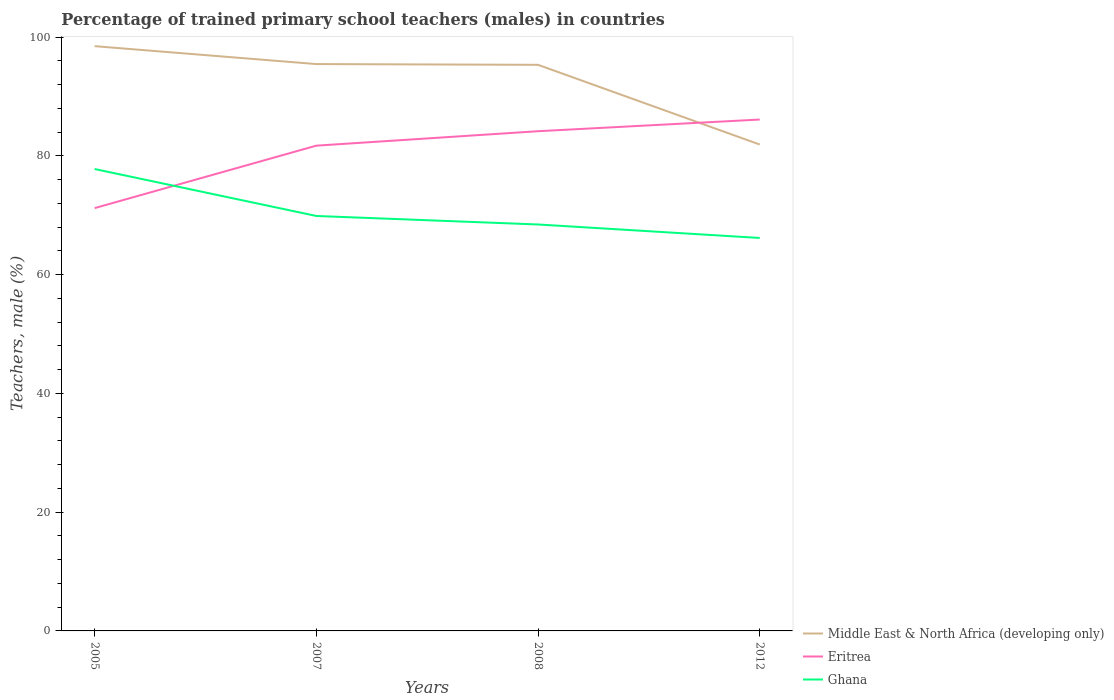Does the line corresponding to Ghana intersect with the line corresponding to Eritrea?
Give a very brief answer. Yes. Across all years, what is the maximum percentage of trained primary school teachers (males) in Middle East & North Africa (developing only)?
Make the answer very short. 81.9. In which year was the percentage of trained primary school teachers (males) in Ghana maximum?
Give a very brief answer. 2012. What is the total percentage of trained primary school teachers (males) in Eritrea in the graph?
Offer a very short reply. -2.43. What is the difference between the highest and the second highest percentage of trained primary school teachers (males) in Eritrea?
Keep it short and to the point. 14.91. What is the difference between the highest and the lowest percentage of trained primary school teachers (males) in Ghana?
Your answer should be very brief. 1. How many years are there in the graph?
Offer a terse response. 4. What is the difference between two consecutive major ticks on the Y-axis?
Provide a succinct answer. 20. Does the graph contain any zero values?
Provide a succinct answer. No. Does the graph contain grids?
Your answer should be very brief. No. How many legend labels are there?
Give a very brief answer. 3. How are the legend labels stacked?
Keep it short and to the point. Vertical. What is the title of the graph?
Ensure brevity in your answer.  Percentage of trained primary school teachers (males) in countries. What is the label or title of the X-axis?
Your response must be concise. Years. What is the label or title of the Y-axis?
Your answer should be compact. Teachers, male (%). What is the Teachers, male (%) in Middle East & North Africa (developing only) in 2005?
Your answer should be compact. 98.46. What is the Teachers, male (%) of Eritrea in 2005?
Provide a short and direct response. 71.19. What is the Teachers, male (%) in Ghana in 2005?
Your answer should be compact. 77.77. What is the Teachers, male (%) in Middle East & North Africa (developing only) in 2007?
Provide a short and direct response. 95.45. What is the Teachers, male (%) in Eritrea in 2007?
Give a very brief answer. 81.71. What is the Teachers, male (%) in Ghana in 2007?
Provide a short and direct response. 69.87. What is the Teachers, male (%) of Middle East & North Africa (developing only) in 2008?
Your response must be concise. 95.32. What is the Teachers, male (%) in Eritrea in 2008?
Provide a short and direct response. 84.14. What is the Teachers, male (%) of Ghana in 2008?
Your response must be concise. 68.44. What is the Teachers, male (%) of Middle East & North Africa (developing only) in 2012?
Make the answer very short. 81.9. What is the Teachers, male (%) in Eritrea in 2012?
Keep it short and to the point. 86.11. What is the Teachers, male (%) in Ghana in 2012?
Offer a very short reply. 66.17. Across all years, what is the maximum Teachers, male (%) in Middle East & North Africa (developing only)?
Provide a short and direct response. 98.46. Across all years, what is the maximum Teachers, male (%) in Eritrea?
Offer a terse response. 86.11. Across all years, what is the maximum Teachers, male (%) of Ghana?
Ensure brevity in your answer.  77.77. Across all years, what is the minimum Teachers, male (%) of Middle East & North Africa (developing only)?
Ensure brevity in your answer.  81.9. Across all years, what is the minimum Teachers, male (%) of Eritrea?
Offer a very short reply. 71.19. Across all years, what is the minimum Teachers, male (%) of Ghana?
Offer a terse response. 66.17. What is the total Teachers, male (%) of Middle East & North Africa (developing only) in the graph?
Your answer should be compact. 371.12. What is the total Teachers, male (%) of Eritrea in the graph?
Your response must be concise. 323.15. What is the total Teachers, male (%) of Ghana in the graph?
Offer a very short reply. 282.24. What is the difference between the Teachers, male (%) of Middle East & North Africa (developing only) in 2005 and that in 2007?
Your answer should be very brief. 3.01. What is the difference between the Teachers, male (%) in Eritrea in 2005 and that in 2007?
Keep it short and to the point. -10.51. What is the difference between the Teachers, male (%) of Ghana in 2005 and that in 2007?
Your answer should be compact. 7.9. What is the difference between the Teachers, male (%) of Middle East & North Africa (developing only) in 2005 and that in 2008?
Keep it short and to the point. 3.14. What is the difference between the Teachers, male (%) in Eritrea in 2005 and that in 2008?
Ensure brevity in your answer.  -12.95. What is the difference between the Teachers, male (%) of Ghana in 2005 and that in 2008?
Offer a very short reply. 9.34. What is the difference between the Teachers, male (%) in Middle East & North Africa (developing only) in 2005 and that in 2012?
Offer a terse response. 16.56. What is the difference between the Teachers, male (%) in Eritrea in 2005 and that in 2012?
Your answer should be compact. -14.91. What is the difference between the Teachers, male (%) in Ghana in 2005 and that in 2012?
Your answer should be compact. 11.61. What is the difference between the Teachers, male (%) in Middle East & North Africa (developing only) in 2007 and that in 2008?
Your answer should be very brief. 0.13. What is the difference between the Teachers, male (%) in Eritrea in 2007 and that in 2008?
Make the answer very short. -2.43. What is the difference between the Teachers, male (%) in Ghana in 2007 and that in 2008?
Your answer should be very brief. 1.43. What is the difference between the Teachers, male (%) of Middle East & North Africa (developing only) in 2007 and that in 2012?
Provide a short and direct response. 13.55. What is the difference between the Teachers, male (%) of Eritrea in 2007 and that in 2012?
Give a very brief answer. -4.4. What is the difference between the Teachers, male (%) in Ghana in 2007 and that in 2012?
Offer a very short reply. 3.7. What is the difference between the Teachers, male (%) of Middle East & North Africa (developing only) in 2008 and that in 2012?
Offer a very short reply. 13.42. What is the difference between the Teachers, male (%) of Eritrea in 2008 and that in 2012?
Make the answer very short. -1.97. What is the difference between the Teachers, male (%) in Ghana in 2008 and that in 2012?
Provide a short and direct response. 2.27. What is the difference between the Teachers, male (%) of Middle East & North Africa (developing only) in 2005 and the Teachers, male (%) of Eritrea in 2007?
Your response must be concise. 16.75. What is the difference between the Teachers, male (%) in Middle East & North Africa (developing only) in 2005 and the Teachers, male (%) in Ghana in 2007?
Provide a succinct answer. 28.59. What is the difference between the Teachers, male (%) of Eritrea in 2005 and the Teachers, male (%) of Ghana in 2007?
Ensure brevity in your answer.  1.32. What is the difference between the Teachers, male (%) of Middle East & North Africa (developing only) in 2005 and the Teachers, male (%) of Eritrea in 2008?
Give a very brief answer. 14.32. What is the difference between the Teachers, male (%) of Middle East & North Africa (developing only) in 2005 and the Teachers, male (%) of Ghana in 2008?
Your response must be concise. 30.03. What is the difference between the Teachers, male (%) in Eritrea in 2005 and the Teachers, male (%) in Ghana in 2008?
Give a very brief answer. 2.76. What is the difference between the Teachers, male (%) in Middle East & North Africa (developing only) in 2005 and the Teachers, male (%) in Eritrea in 2012?
Offer a terse response. 12.35. What is the difference between the Teachers, male (%) in Middle East & North Africa (developing only) in 2005 and the Teachers, male (%) in Ghana in 2012?
Your answer should be compact. 32.29. What is the difference between the Teachers, male (%) of Eritrea in 2005 and the Teachers, male (%) of Ghana in 2012?
Offer a terse response. 5.03. What is the difference between the Teachers, male (%) in Middle East & North Africa (developing only) in 2007 and the Teachers, male (%) in Eritrea in 2008?
Your answer should be very brief. 11.31. What is the difference between the Teachers, male (%) of Middle East & North Africa (developing only) in 2007 and the Teachers, male (%) of Ghana in 2008?
Keep it short and to the point. 27.01. What is the difference between the Teachers, male (%) in Eritrea in 2007 and the Teachers, male (%) in Ghana in 2008?
Your response must be concise. 13.27. What is the difference between the Teachers, male (%) of Middle East & North Africa (developing only) in 2007 and the Teachers, male (%) of Eritrea in 2012?
Provide a short and direct response. 9.34. What is the difference between the Teachers, male (%) of Middle East & North Africa (developing only) in 2007 and the Teachers, male (%) of Ghana in 2012?
Give a very brief answer. 29.28. What is the difference between the Teachers, male (%) of Eritrea in 2007 and the Teachers, male (%) of Ghana in 2012?
Keep it short and to the point. 15.54. What is the difference between the Teachers, male (%) of Middle East & North Africa (developing only) in 2008 and the Teachers, male (%) of Eritrea in 2012?
Make the answer very short. 9.21. What is the difference between the Teachers, male (%) in Middle East & North Africa (developing only) in 2008 and the Teachers, male (%) in Ghana in 2012?
Keep it short and to the point. 29.15. What is the difference between the Teachers, male (%) of Eritrea in 2008 and the Teachers, male (%) of Ghana in 2012?
Offer a very short reply. 17.97. What is the average Teachers, male (%) in Middle East & North Africa (developing only) per year?
Give a very brief answer. 92.78. What is the average Teachers, male (%) in Eritrea per year?
Your answer should be very brief. 80.79. What is the average Teachers, male (%) in Ghana per year?
Provide a succinct answer. 70.56. In the year 2005, what is the difference between the Teachers, male (%) of Middle East & North Africa (developing only) and Teachers, male (%) of Eritrea?
Your answer should be very brief. 27.27. In the year 2005, what is the difference between the Teachers, male (%) in Middle East & North Africa (developing only) and Teachers, male (%) in Ghana?
Ensure brevity in your answer.  20.69. In the year 2005, what is the difference between the Teachers, male (%) of Eritrea and Teachers, male (%) of Ghana?
Make the answer very short. -6.58. In the year 2007, what is the difference between the Teachers, male (%) in Middle East & North Africa (developing only) and Teachers, male (%) in Eritrea?
Offer a terse response. 13.74. In the year 2007, what is the difference between the Teachers, male (%) of Middle East & North Africa (developing only) and Teachers, male (%) of Ghana?
Your response must be concise. 25.58. In the year 2007, what is the difference between the Teachers, male (%) in Eritrea and Teachers, male (%) in Ghana?
Keep it short and to the point. 11.84. In the year 2008, what is the difference between the Teachers, male (%) in Middle East & North Africa (developing only) and Teachers, male (%) in Eritrea?
Give a very brief answer. 11.18. In the year 2008, what is the difference between the Teachers, male (%) in Middle East & North Africa (developing only) and Teachers, male (%) in Ghana?
Your response must be concise. 26.88. In the year 2008, what is the difference between the Teachers, male (%) of Eritrea and Teachers, male (%) of Ghana?
Provide a short and direct response. 15.71. In the year 2012, what is the difference between the Teachers, male (%) of Middle East & North Africa (developing only) and Teachers, male (%) of Eritrea?
Ensure brevity in your answer.  -4.21. In the year 2012, what is the difference between the Teachers, male (%) of Middle East & North Africa (developing only) and Teachers, male (%) of Ghana?
Provide a succinct answer. 15.73. In the year 2012, what is the difference between the Teachers, male (%) of Eritrea and Teachers, male (%) of Ghana?
Keep it short and to the point. 19.94. What is the ratio of the Teachers, male (%) of Middle East & North Africa (developing only) in 2005 to that in 2007?
Your answer should be very brief. 1.03. What is the ratio of the Teachers, male (%) of Eritrea in 2005 to that in 2007?
Ensure brevity in your answer.  0.87. What is the ratio of the Teachers, male (%) of Ghana in 2005 to that in 2007?
Give a very brief answer. 1.11. What is the ratio of the Teachers, male (%) in Middle East & North Africa (developing only) in 2005 to that in 2008?
Your answer should be compact. 1.03. What is the ratio of the Teachers, male (%) of Eritrea in 2005 to that in 2008?
Provide a succinct answer. 0.85. What is the ratio of the Teachers, male (%) of Ghana in 2005 to that in 2008?
Keep it short and to the point. 1.14. What is the ratio of the Teachers, male (%) in Middle East & North Africa (developing only) in 2005 to that in 2012?
Your answer should be compact. 1.2. What is the ratio of the Teachers, male (%) in Eritrea in 2005 to that in 2012?
Provide a short and direct response. 0.83. What is the ratio of the Teachers, male (%) of Ghana in 2005 to that in 2012?
Offer a terse response. 1.18. What is the ratio of the Teachers, male (%) of Middle East & North Africa (developing only) in 2007 to that in 2008?
Your answer should be very brief. 1. What is the ratio of the Teachers, male (%) in Eritrea in 2007 to that in 2008?
Your response must be concise. 0.97. What is the ratio of the Teachers, male (%) in Middle East & North Africa (developing only) in 2007 to that in 2012?
Provide a short and direct response. 1.17. What is the ratio of the Teachers, male (%) in Eritrea in 2007 to that in 2012?
Offer a very short reply. 0.95. What is the ratio of the Teachers, male (%) of Ghana in 2007 to that in 2012?
Give a very brief answer. 1.06. What is the ratio of the Teachers, male (%) of Middle East & North Africa (developing only) in 2008 to that in 2012?
Make the answer very short. 1.16. What is the ratio of the Teachers, male (%) of Eritrea in 2008 to that in 2012?
Your response must be concise. 0.98. What is the ratio of the Teachers, male (%) in Ghana in 2008 to that in 2012?
Your response must be concise. 1.03. What is the difference between the highest and the second highest Teachers, male (%) of Middle East & North Africa (developing only)?
Offer a terse response. 3.01. What is the difference between the highest and the second highest Teachers, male (%) of Eritrea?
Offer a terse response. 1.97. What is the difference between the highest and the second highest Teachers, male (%) of Ghana?
Provide a short and direct response. 7.9. What is the difference between the highest and the lowest Teachers, male (%) in Middle East & North Africa (developing only)?
Provide a short and direct response. 16.56. What is the difference between the highest and the lowest Teachers, male (%) of Eritrea?
Provide a short and direct response. 14.91. What is the difference between the highest and the lowest Teachers, male (%) in Ghana?
Provide a short and direct response. 11.61. 